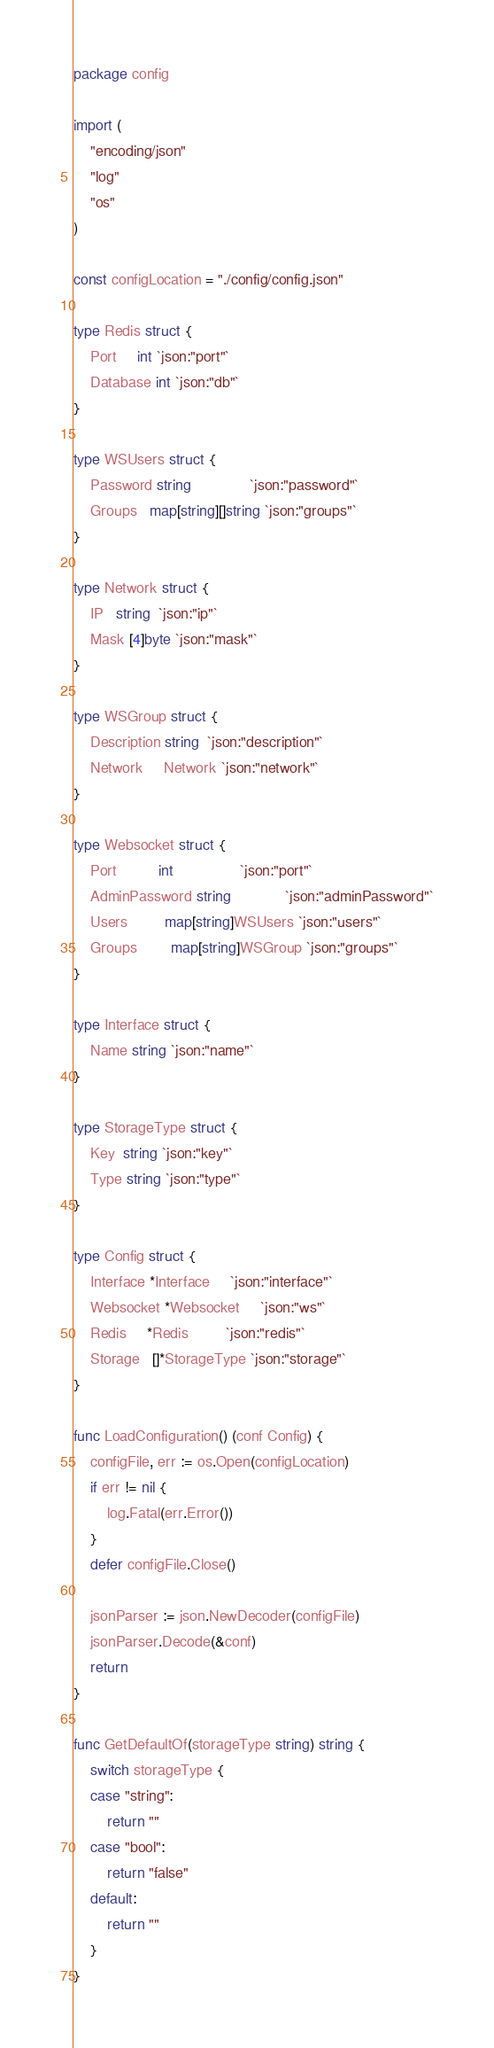<code> <loc_0><loc_0><loc_500><loc_500><_Go_>package config

import (
	"encoding/json"
	"log"
	"os"
)

const configLocation = "./config/config.json"

type Redis struct {
	Port     int `json:"port"`
	Database int `json:"db"`
}

type WSUsers struct {
	Password string              `json:"password"`
	Groups   map[string][]string `json:"groups"`
}

type Network struct {
	IP   string  `json:"ip"`
	Mask [4]byte `json:"mask"`
}

type WSGroup struct {
	Description string  `json:"description"`
	Network     Network `json:"network"`
}

type Websocket struct {
	Port          int                `json:"port"`
	AdminPassword string             `json:"adminPassword"`
	Users         map[string]WSUsers `json:"users"`
	Groups        map[string]WSGroup `json:"groups"`
}

type Interface struct {
	Name string `json:"name"`
}

type StorageType struct {
	Key  string `json:"key"`
	Type string `json:"type"`
}

type Config struct {
	Interface *Interface     `json:"interface"`
	Websocket *Websocket     `json:"ws"`
	Redis     *Redis         `json:"redis"`
	Storage   []*StorageType `json:"storage"`
}

func LoadConfiguration() (conf Config) {
	configFile, err := os.Open(configLocation)
	if err != nil {
		log.Fatal(err.Error())
	}
	defer configFile.Close()

	jsonParser := json.NewDecoder(configFile)
	jsonParser.Decode(&conf)
	return
}

func GetDefaultOf(storageType string) string {
	switch storageType {
	case "string":
		return ""
	case "bool":
		return "false"
	default:
		return ""
	}
}
</code> 